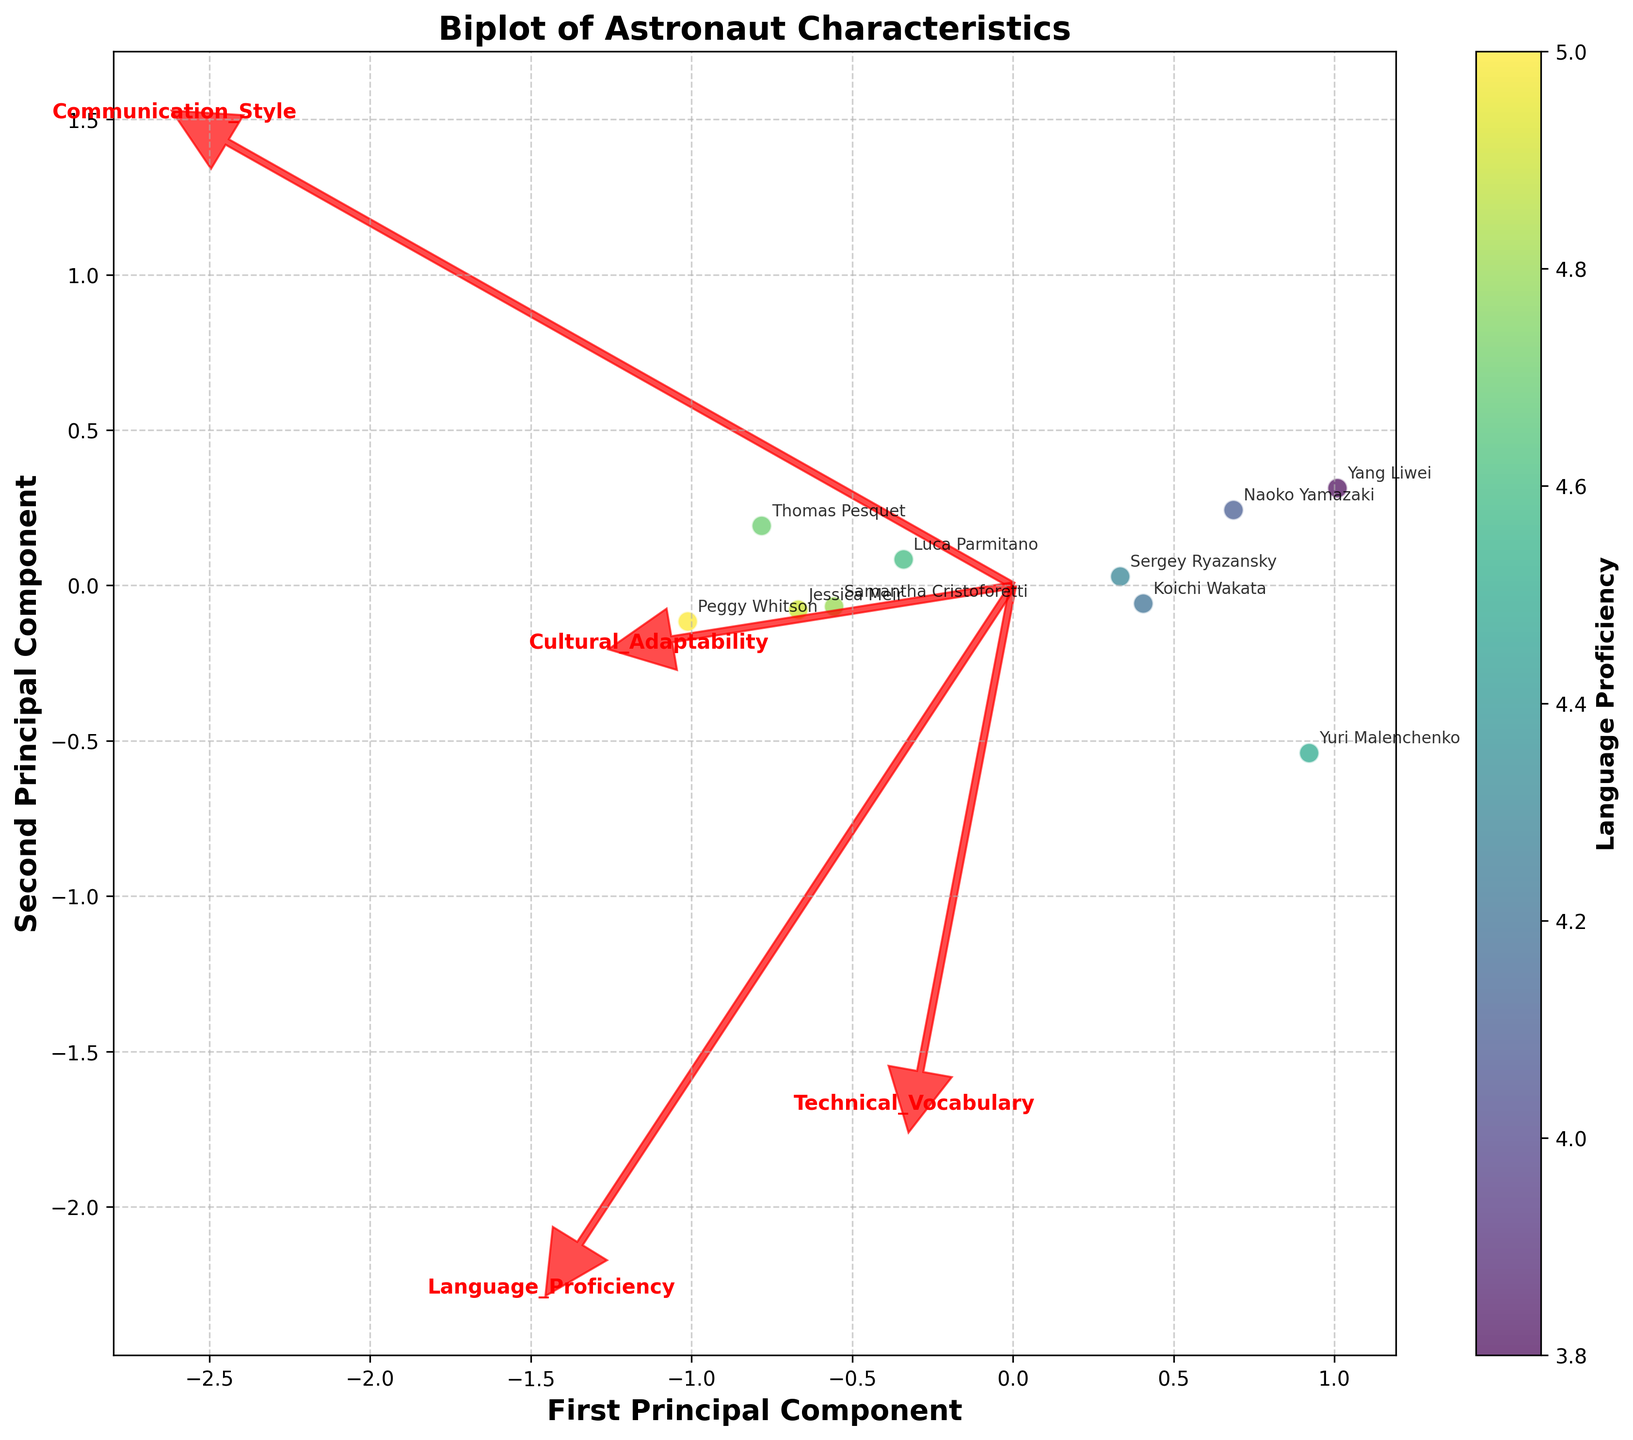What is the range of the color bar representing Language Proficiency? The color bar on the biplot indicates the range of Language Proficiency from the minimum value to the maximum value. By looking at the color bar's endpoints, we see it spans from approximately 3.8 to 5.0.
Answer: 3.8 to 5.0 Which astronaut has the highest Language Proficiency? The color bar can be used to determine the Language Proficiency, but the scatter plot also shows the names of astronauts near the points. The point labeled "Peggy Whitson" falls within the highest range on the color bar, indicating she has the highest Language Proficiency.
Answer: Peggy Whitson What are the labels for the feature vectors shown in red? The feature vectors in red are associated with the four characteristics being examined in the biplot. By looking at the annotation at the end of each arrow, they represent: Language Proficiency, Communication Style, Cultural Adaptability, and Technical Vocabulary.
Answer: Language Proficiency, Communication Style, Cultural Adaptability, Technical Vocabulary Which astronaut appears to have the highest score in Technical Vocabulary? The direction of the feature vector labeled "Technical Vocabulary" shows positive values along that axis. By identifying the point aligned most closely with this arrow, "Peggy Whitson" has the highest Technical Vocabulary score.
Answer: Peggy Whitson Which two astronauts are closest in the first principal component? The first principal component is the x-axis on the biplot. By examining the horizontal positions of the points, "Koichi Wakata" and "Sergey Ryazansky" appear closest to each other horizontally.
Answer: Koichi Wakata and Sergey Ryazansky What is the title of the plot? The title is displayed at the top of the plot. It reads "Biplot of Astronaut Characteristics."
Answer: Biplot of Astronaut Characteristics How do the Cultural Adaptability and Communication Style vectors compare in length? To determine the relative lengths, look at the arrows corresponding to these feature vectors. The arrow for Communication Style extends further from the origin than the arrow for Cultural Adaptability, indicating that Communication Style has a higher variance than Cultural Adaptability in the dataset.
Answer: Communication Style vector is longer Which characteristic seems least correlated with the first principal component? The characteristic with the feature vector closest to the vertical axis (second principal component) will have the least correlation with the first principal component. "Communication Style" is almost perpendicular to the horizontal axis, indicating a low correlation with the first principal component.
Answer: Communication Style Which two astronauts show the greatest difference in their positions along the second principal component? The second principal component is the y-axis. By examining the vertical spread of the points, "Peggy Whitson" and "Yuri Malenchenko" show the greatest difference in their vertical positions.
Answer: Peggy Whitson and Yuri Malenchenko 